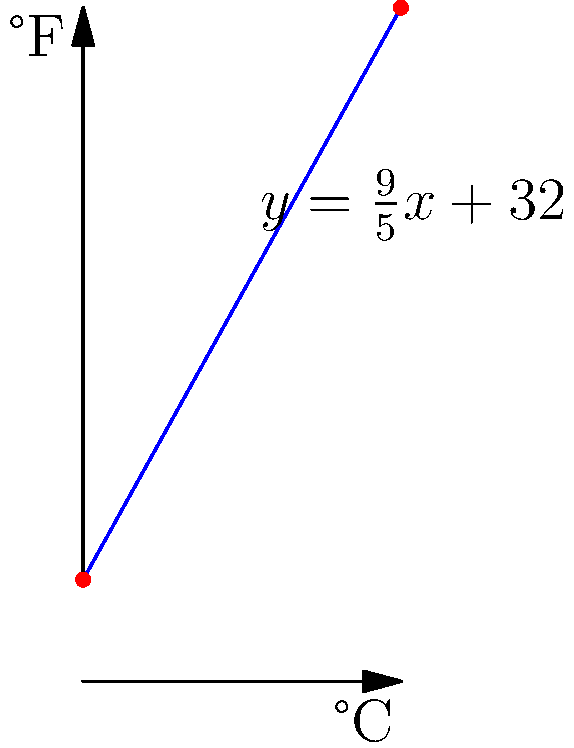The graph shows the relationship between Celsius (°C) and Fahrenheit (°F) temperatures. If the temperature in Tokyo drops from 25°C to 15°C overnight, what is the corresponding change in Fahrenheit? To solve this problem, we'll follow these steps:

1) The formula for converting Celsius to Fahrenheit is:
   $F = \frac{9}{5}C + 32$

2) Let's calculate the Fahrenheit temperatures for both 25°C and 15°C:

   For 25°C:
   $F_1 = \frac{9}{5}(25) + 32 = 45 + 32 = 77°F$

   For 15°C:
   $F_2 = \frac{9}{5}(15) + 32 = 27 + 32 = 59°F$

3) Now, we need to find the difference between these two Fahrenheit temperatures:

   $\Delta F = F_1 - F_2 = 77°F - 59°F = 18°F$

4) We can also observe from the graph that the line is straight, indicating a linear relationship. The change in Fahrenheit is proportional to the change in Celsius, with a factor of $\frac{9}{5}$ or 1.8.

   We can verify this: $\Delta C = 25°C - 15°C = 10°C$
   $\Delta F = \frac{9}{5}(10°C) = 18°F$

Therefore, when the temperature drops by 10°C, it corresponds to a drop of 18°F.
Answer: 18°F 